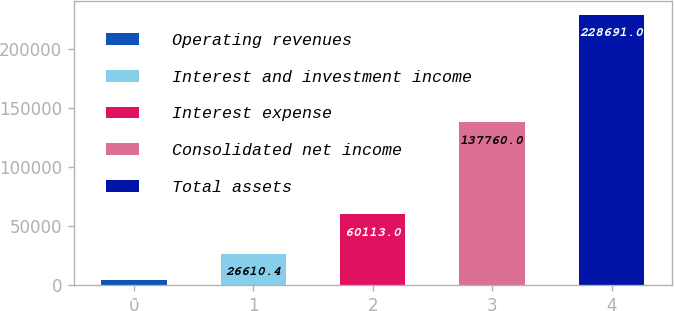<chart> <loc_0><loc_0><loc_500><loc_500><bar_chart><fcel>Operating revenues<fcel>Interest and investment income<fcel>Interest expense<fcel>Consolidated net income<fcel>Total assets<nl><fcel>4157<fcel>26610.4<fcel>60113<fcel>137760<fcel>228691<nl></chart> 